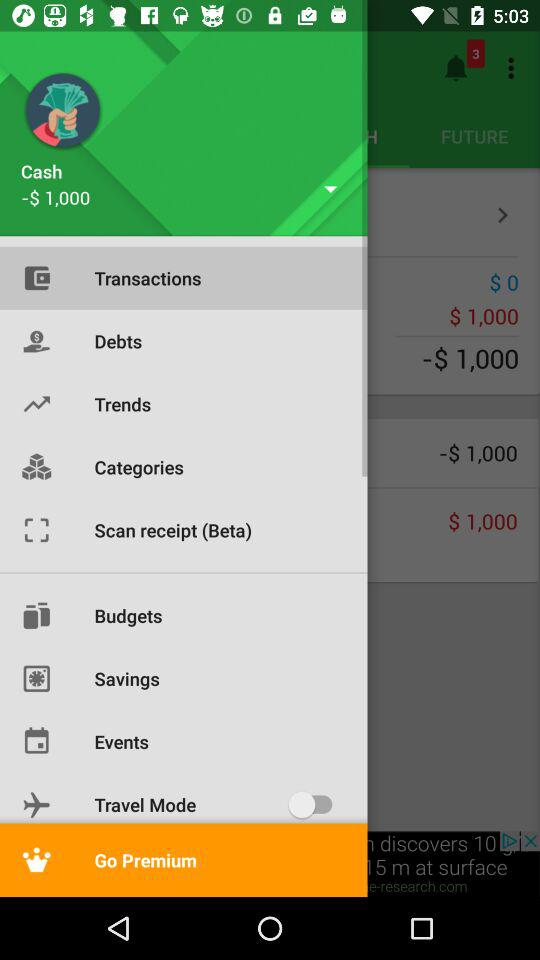Which item is selected? The selected item is "Transactions". 